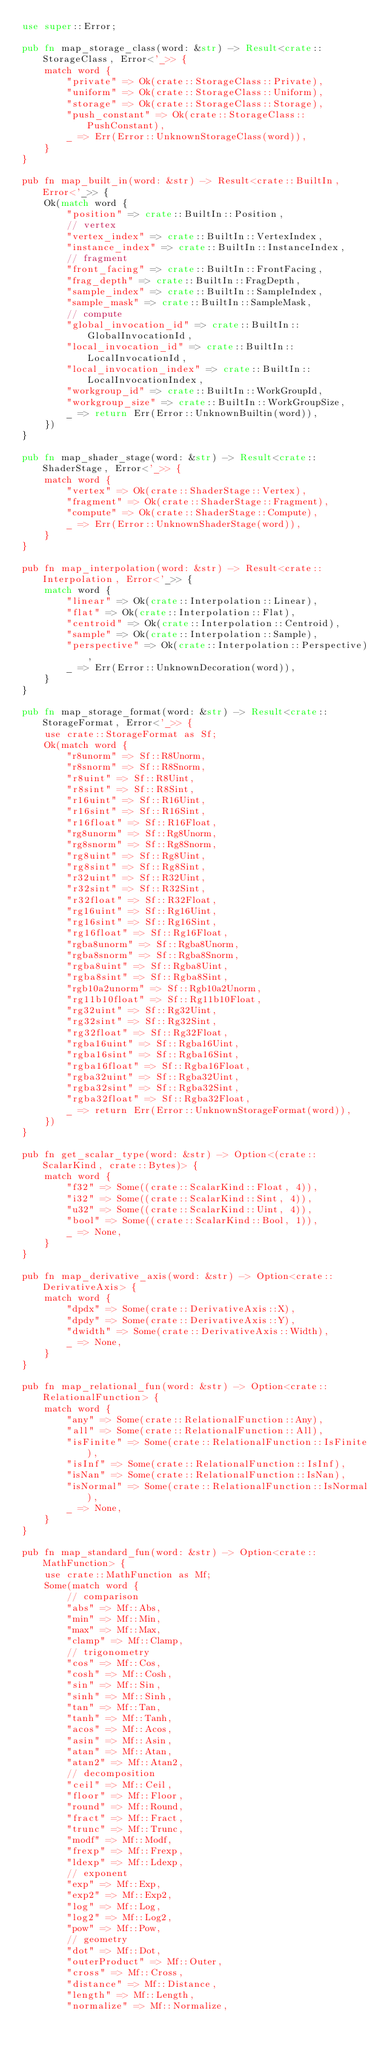<code> <loc_0><loc_0><loc_500><loc_500><_Rust_>use super::Error;

pub fn map_storage_class(word: &str) -> Result<crate::StorageClass, Error<'_>> {
    match word {
        "private" => Ok(crate::StorageClass::Private),
        "uniform" => Ok(crate::StorageClass::Uniform),
        "storage" => Ok(crate::StorageClass::Storage),
        "push_constant" => Ok(crate::StorageClass::PushConstant),
        _ => Err(Error::UnknownStorageClass(word)),
    }
}

pub fn map_built_in(word: &str) -> Result<crate::BuiltIn, Error<'_>> {
    Ok(match word {
        "position" => crate::BuiltIn::Position,
        // vertex
        "vertex_index" => crate::BuiltIn::VertexIndex,
        "instance_index" => crate::BuiltIn::InstanceIndex,
        // fragment
        "front_facing" => crate::BuiltIn::FrontFacing,
        "frag_depth" => crate::BuiltIn::FragDepth,
        "sample_index" => crate::BuiltIn::SampleIndex,
        "sample_mask" => crate::BuiltIn::SampleMask,
        // compute
        "global_invocation_id" => crate::BuiltIn::GlobalInvocationId,
        "local_invocation_id" => crate::BuiltIn::LocalInvocationId,
        "local_invocation_index" => crate::BuiltIn::LocalInvocationIndex,
        "workgroup_id" => crate::BuiltIn::WorkGroupId,
        "workgroup_size" => crate::BuiltIn::WorkGroupSize,
        _ => return Err(Error::UnknownBuiltin(word)),
    })
}

pub fn map_shader_stage(word: &str) -> Result<crate::ShaderStage, Error<'_>> {
    match word {
        "vertex" => Ok(crate::ShaderStage::Vertex),
        "fragment" => Ok(crate::ShaderStage::Fragment),
        "compute" => Ok(crate::ShaderStage::Compute),
        _ => Err(Error::UnknownShaderStage(word)),
    }
}

pub fn map_interpolation(word: &str) -> Result<crate::Interpolation, Error<'_>> {
    match word {
        "linear" => Ok(crate::Interpolation::Linear),
        "flat" => Ok(crate::Interpolation::Flat),
        "centroid" => Ok(crate::Interpolation::Centroid),
        "sample" => Ok(crate::Interpolation::Sample),
        "perspective" => Ok(crate::Interpolation::Perspective),
        _ => Err(Error::UnknownDecoration(word)),
    }
}

pub fn map_storage_format(word: &str) -> Result<crate::StorageFormat, Error<'_>> {
    use crate::StorageFormat as Sf;
    Ok(match word {
        "r8unorm" => Sf::R8Unorm,
        "r8snorm" => Sf::R8Snorm,
        "r8uint" => Sf::R8Uint,
        "r8sint" => Sf::R8Sint,
        "r16uint" => Sf::R16Uint,
        "r16sint" => Sf::R16Sint,
        "r16float" => Sf::R16Float,
        "rg8unorm" => Sf::Rg8Unorm,
        "rg8snorm" => Sf::Rg8Snorm,
        "rg8uint" => Sf::Rg8Uint,
        "rg8sint" => Sf::Rg8Sint,
        "r32uint" => Sf::R32Uint,
        "r32sint" => Sf::R32Sint,
        "r32float" => Sf::R32Float,
        "rg16uint" => Sf::Rg16Uint,
        "rg16sint" => Sf::Rg16Sint,
        "rg16float" => Sf::Rg16Float,
        "rgba8unorm" => Sf::Rgba8Unorm,
        "rgba8snorm" => Sf::Rgba8Snorm,
        "rgba8uint" => Sf::Rgba8Uint,
        "rgba8sint" => Sf::Rgba8Sint,
        "rgb10a2unorm" => Sf::Rgb10a2Unorm,
        "rg11b10float" => Sf::Rg11b10Float,
        "rg32uint" => Sf::Rg32Uint,
        "rg32sint" => Sf::Rg32Sint,
        "rg32float" => Sf::Rg32Float,
        "rgba16uint" => Sf::Rgba16Uint,
        "rgba16sint" => Sf::Rgba16Sint,
        "rgba16float" => Sf::Rgba16Float,
        "rgba32uint" => Sf::Rgba32Uint,
        "rgba32sint" => Sf::Rgba32Sint,
        "rgba32float" => Sf::Rgba32Float,
        _ => return Err(Error::UnknownStorageFormat(word)),
    })
}

pub fn get_scalar_type(word: &str) -> Option<(crate::ScalarKind, crate::Bytes)> {
    match word {
        "f32" => Some((crate::ScalarKind::Float, 4)),
        "i32" => Some((crate::ScalarKind::Sint, 4)),
        "u32" => Some((crate::ScalarKind::Uint, 4)),
        "bool" => Some((crate::ScalarKind::Bool, 1)),
        _ => None,
    }
}

pub fn map_derivative_axis(word: &str) -> Option<crate::DerivativeAxis> {
    match word {
        "dpdx" => Some(crate::DerivativeAxis::X),
        "dpdy" => Some(crate::DerivativeAxis::Y),
        "dwidth" => Some(crate::DerivativeAxis::Width),
        _ => None,
    }
}

pub fn map_relational_fun(word: &str) -> Option<crate::RelationalFunction> {
    match word {
        "any" => Some(crate::RelationalFunction::Any),
        "all" => Some(crate::RelationalFunction::All),
        "isFinite" => Some(crate::RelationalFunction::IsFinite),
        "isInf" => Some(crate::RelationalFunction::IsInf),
        "isNan" => Some(crate::RelationalFunction::IsNan),
        "isNormal" => Some(crate::RelationalFunction::IsNormal),
        _ => None,
    }
}

pub fn map_standard_fun(word: &str) -> Option<crate::MathFunction> {
    use crate::MathFunction as Mf;
    Some(match word {
        // comparison
        "abs" => Mf::Abs,
        "min" => Mf::Min,
        "max" => Mf::Max,
        "clamp" => Mf::Clamp,
        // trigonometry
        "cos" => Mf::Cos,
        "cosh" => Mf::Cosh,
        "sin" => Mf::Sin,
        "sinh" => Mf::Sinh,
        "tan" => Mf::Tan,
        "tanh" => Mf::Tanh,
        "acos" => Mf::Acos,
        "asin" => Mf::Asin,
        "atan" => Mf::Atan,
        "atan2" => Mf::Atan2,
        // decomposition
        "ceil" => Mf::Ceil,
        "floor" => Mf::Floor,
        "round" => Mf::Round,
        "fract" => Mf::Fract,
        "trunc" => Mf::Trunc,
        "modf" => Mf::Modf,
        "frexp" => Mf::Frexp,
        "ldexp" => Mf::Ldexp,
        // exponent
        "exp" => Mf::Exp,
        "exp2" => Mf::Exp2,
        "log" => Mf::Log,
        "log2" => Mf::Log2,
        "pow" => Mf::Pow,
        // geometry
        "dot" => Mf::Dot,
        "outerProduct" => Mf::Outer,
        "cross" => Mf::Cross,
        "distance" => Mf::Distance,
        "length" => Mf::Length,
        "normalize" => Mf::Normalize,</code> 